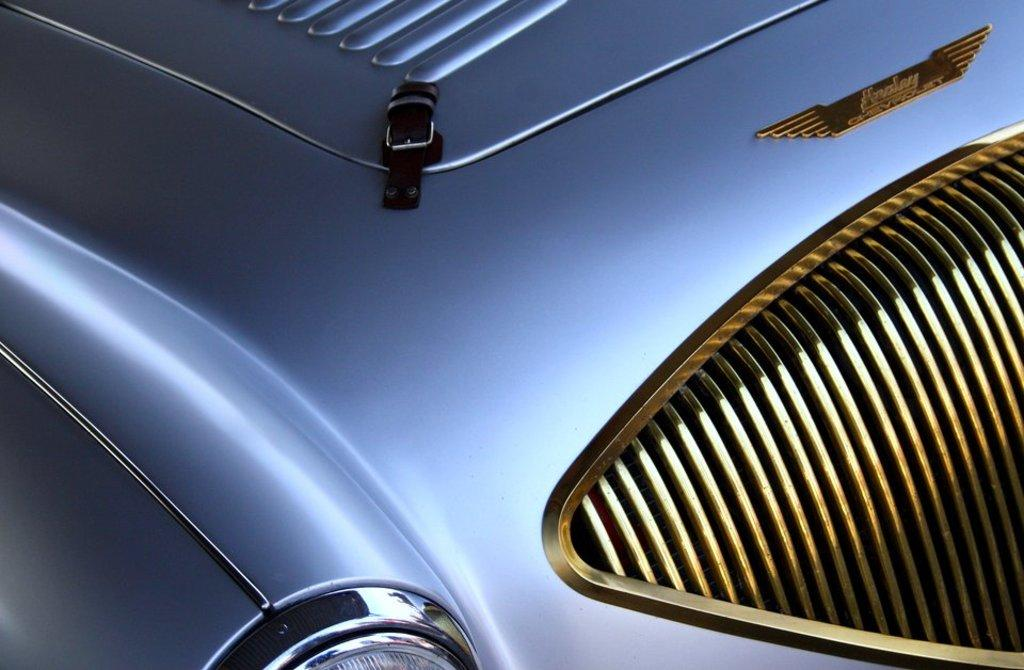What type of vehicle is partially visible in the image? There is a part of a car in the image. Can you describe the lighting condition at the bottom of the image? There is light visible at the bottom of the image. Where is the kitty playing with a cactus in the image? There is no kitty or cactus present in the image. What type of humor can be observed in the image? There is no humor depicted in the image; it features a part of a car and light at the bottom. 